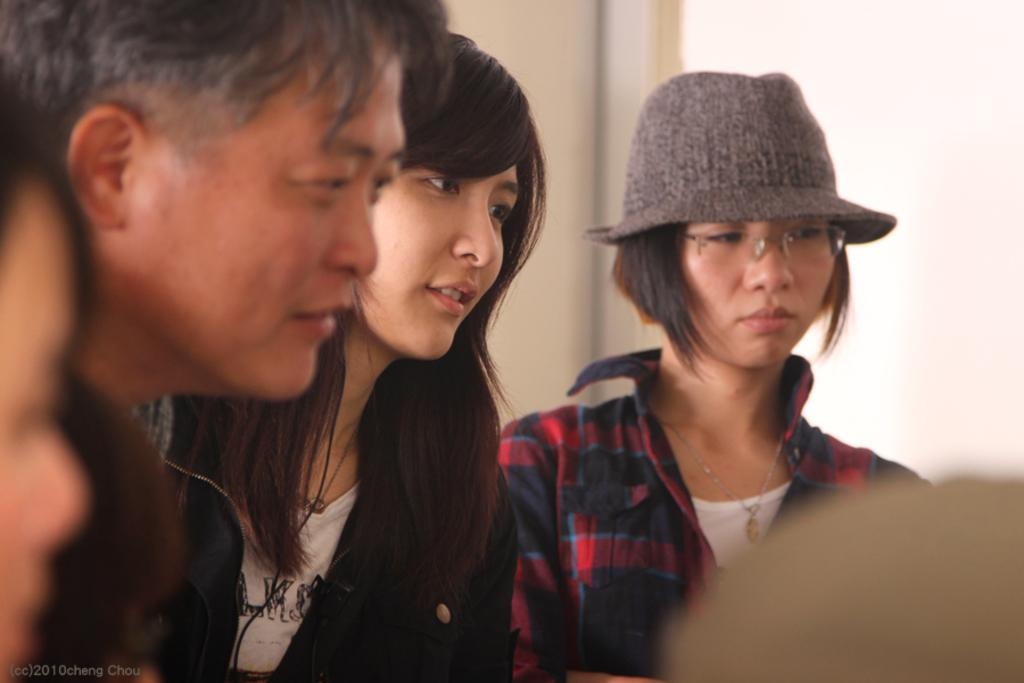What is happening in the image? There are groups of people standing in the image. What can be seen behind the people in the image? There is a wall behind the people in the image. Is there any additional information about the image itself? Yes, there is a watermark on the image. What type of fork can be seen in the hands of the people in the image? There are no forks present in the image; the people are standing without any visible objects in their hands. 